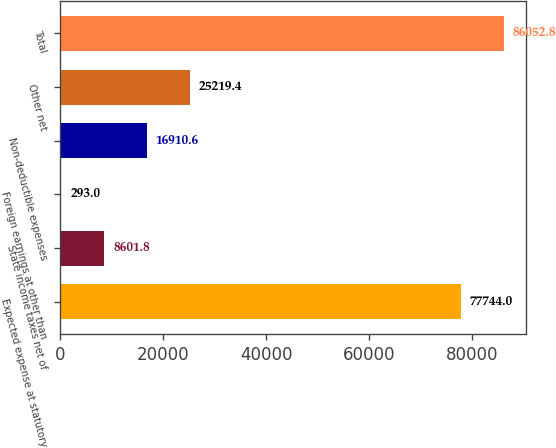Convert chart. <chart><loc_0><loc_0><loc_500><loc_500><bar_chart><fcel>Expected expense at statutory<fcel>State income taxes net of<fcel>Foreign earnings at other than<fcel>Non-deductible expenses<fcel>Other net<fcel>Total<nl><fcel>77744<fcel>8601.8<fcel>293<fcel>16910.6<fcel>25219.4<fcel>86052.8<nl></chart> 